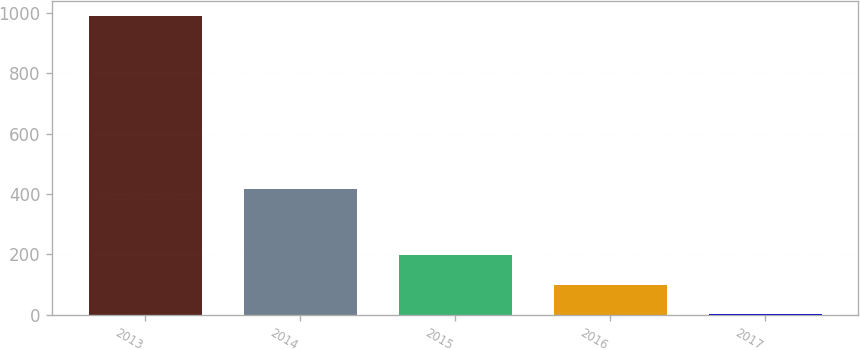Convert chart. <chart><loc_0><loc_0><loc_500><loc_500><bar_chart><fcel>2013<fcel>2014<fcel>2015<fcel>2016<fcel>2017<nl><fcel>991<fcel>417<fcel>199<fcel>100<fcel>1<nl></chart> 